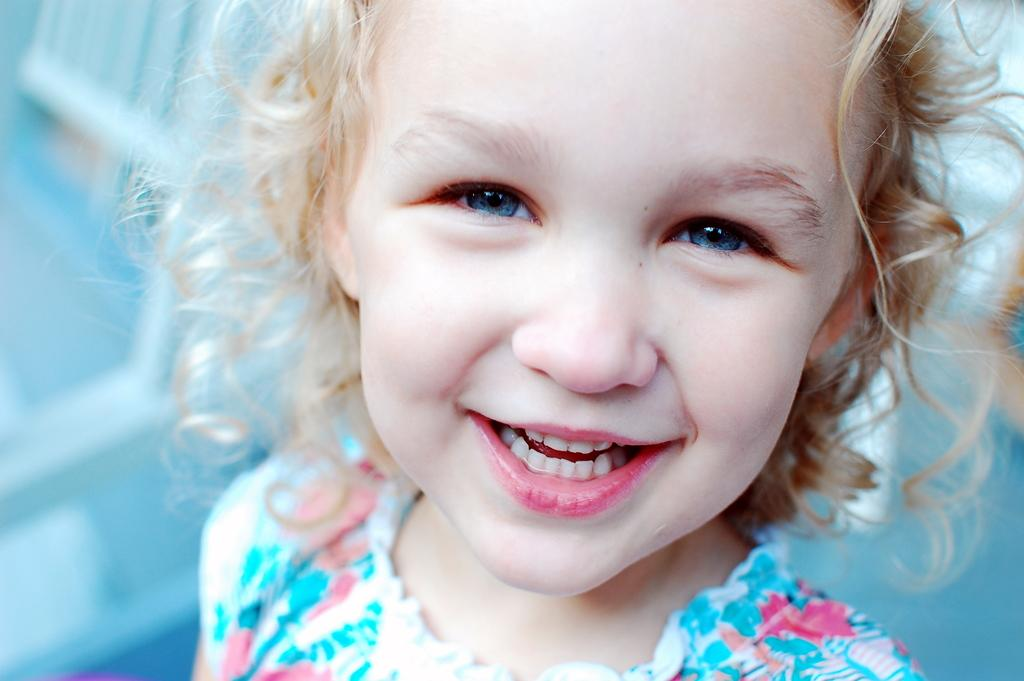What is the main subject of the image? The main subject of the image is a little girl. What is the little girl doing in the image? The little girl is smiling. What type of pin is the little girl wearing on her back in the image? There is no pin visible on the little girl in the image. What is the little girl cooking on the stove in the image? There is no stove or cooking activity present in the image. 